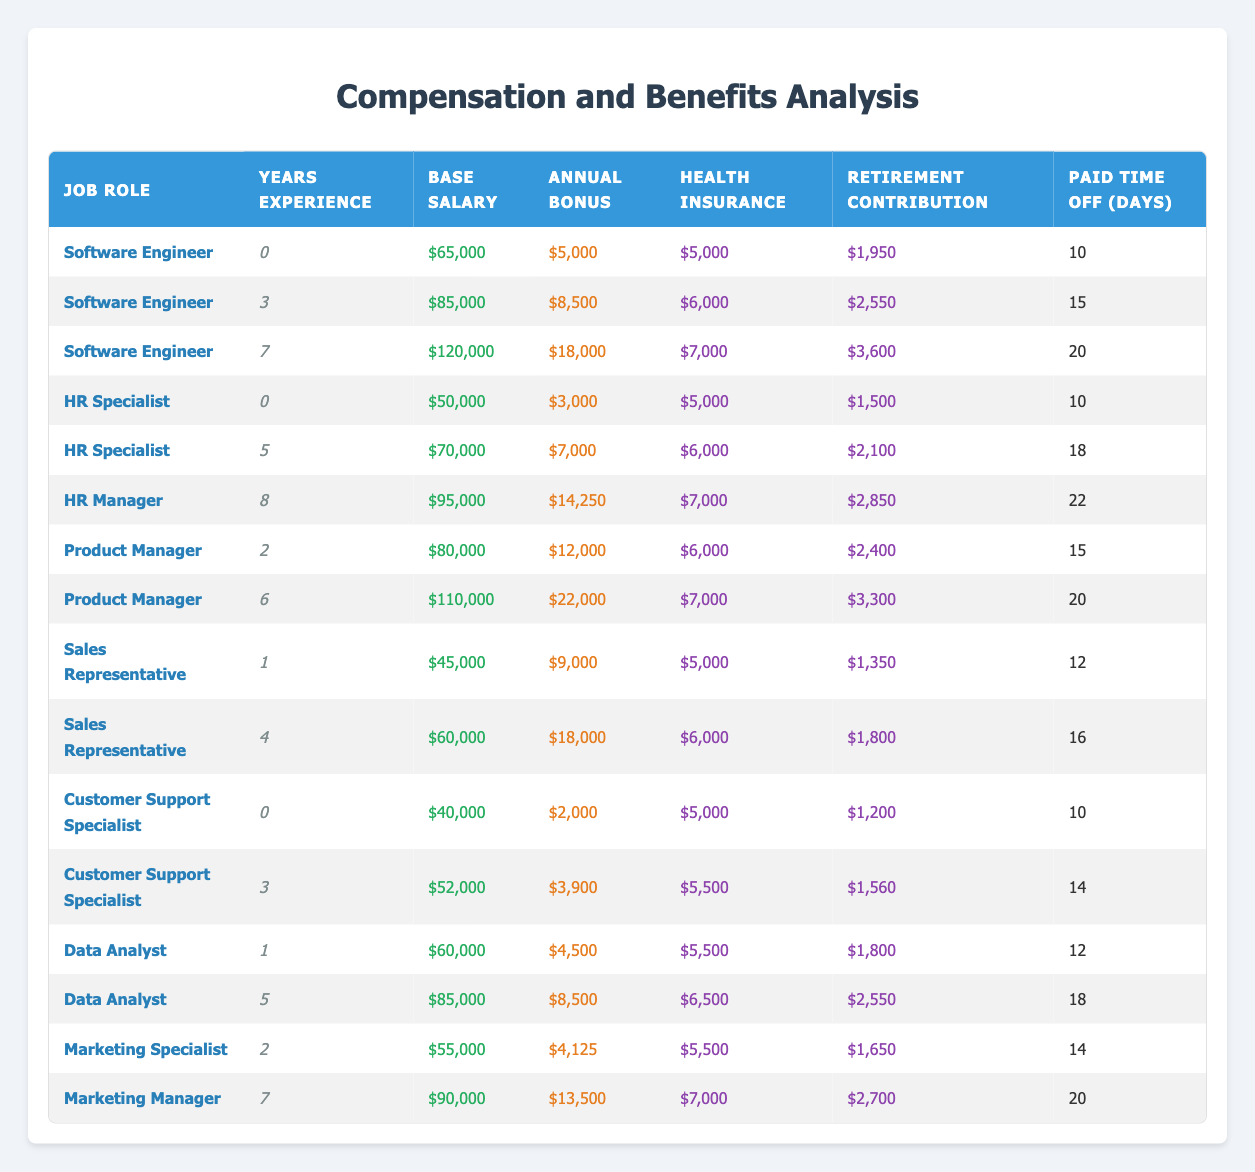What is the base salary for a Software Engineer with 7 years of experience? From the table, locate the row with the Job Role of "Software Engineer" and Years Experience of 7. The base salary listed there is $120,000.
Answer: $120,000 What is the total annual bonus for all HR Specialists listed? The bonuses for each HR Specialist are $3,000 for 0 years of experience and $7,000 for 5 years of experience. Adding these gives $3,000 + $7,000 = $10,000.
Answer: $10,000 Are the health insurance benefits higher for Data Analysts with 5 years of experience compared to Sales Representatives with 4 years of experience? The health insurance benefit for Data Analysts with 5 years of experience is $6,500, while for Sales Representatives with 4 years of experience, it is $6,000. Since 6,500 > 6,000, the statement is true.
Answer: Yes What is the average paid time off for a Product Manager? There are two entries for Product Managers: one with 2 years of experience, who receives 15 days of paid time off, and one with 6 years of experience, who receives 20 days. The average is (15 + 20) / 2 = 17.5 days.
Answer: 17.5 days Which job role has the highest annual bonus listed and what is that amount? Reviewing the annual bonus column, the Software Engineer with 7 years of experience has the highest bonus at $18,000.
Answer: $18,000 If you combine the base salaries of all Customer Support Specialists, what is the total? The base salaries for Customer Support Specialists are $40,000 (0 years of experience) and $52,000 (3 years of experience). Adding them together gives $40,000 + $52,000 = $92,000.
Answer: $92,000 Is it true that all roles with more than 5 years of experience have a base salary above $80,000? Analyzing the roles with more than 5 years, the HR Manager (8 years) has a base salary of $95,000, and the Software Engineer (7 years) has $120,000. In this case, both exceed $80,000, which supports the fact.
Answer: Yes What is the difference in health insurance benefits between a Software Engineer with 3 years of experience and an HR Specialist with 5 years of experience? The health insurance for a Software Engineer with 3 years of experience is $6,000 and for an HR Specialist with 5 years is $6,000 as well. The difference is $6,000 - $6,000 = $0.
Answer: $0 What is the highest retirement contribution listed, and for which job role and experience level does it apply? The highest retirement contribution of $3,600 corresponds to a Software Engineer with 7 years of experience.
Answer: $3,600, Software Engineer, 7 years 